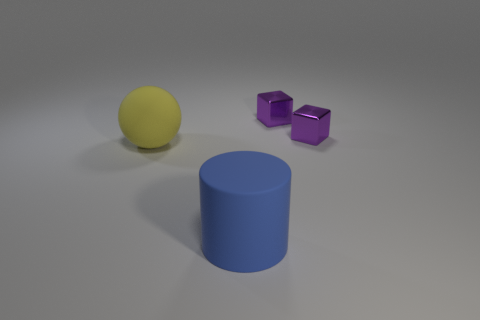What color is the big cylinder?
Your response must be concise. Blue. There is a thing in front of the big sphere; is it the same shape as the large yellow thing?
Give a very brief answer. No. How many objects are either small cubes or big objects to the right of the yellow sphere?
Ensure brevity in your answer.  3. What is the object in front of the matte object on the left side of the blue object made of?
Provide a short and direct response. Rubber. Are there more tiny purple metallic objects right of the large blue rubber thing than matte objects that are behind the yellow rubber thing?
Keep it short and to the point. Yes. What size is the blue rubber thing?
Your answer should be compact. Large. Is there any other thing that has the same shape as the big yellow object?
Make the answer very short. No. There is a thing that is in front of the large yellow sphere; are there any metallic things behind it?
Provide a succinct answer. Yes. Are there fewer spheres that are in front of the blue object than large rubber cylinders in front of the yellow matte thing?
Keep it short and to the point. Yes. Do the rubber thing that is behind the blue thing and the blue cylinder have the same size?
Provide a short and direct response. Yes. 